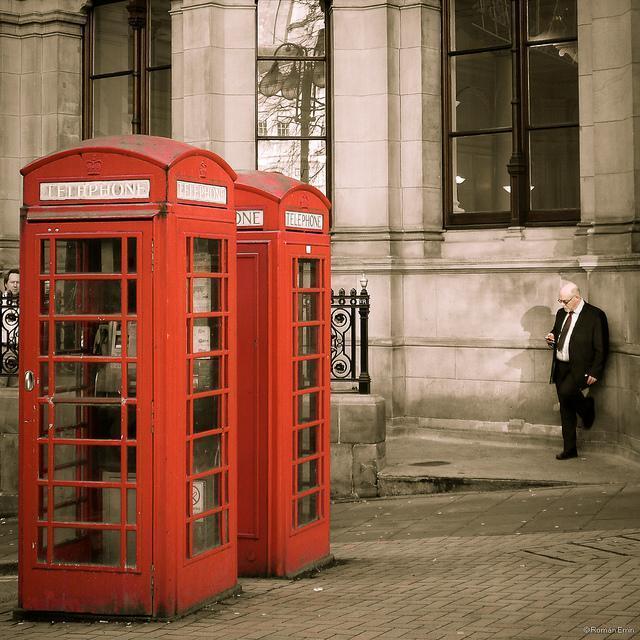How many outhouses are in this scene?
Give a very brief answer. 0. How many brown cows are there on the beach?
Give a very brief answer. 0. 